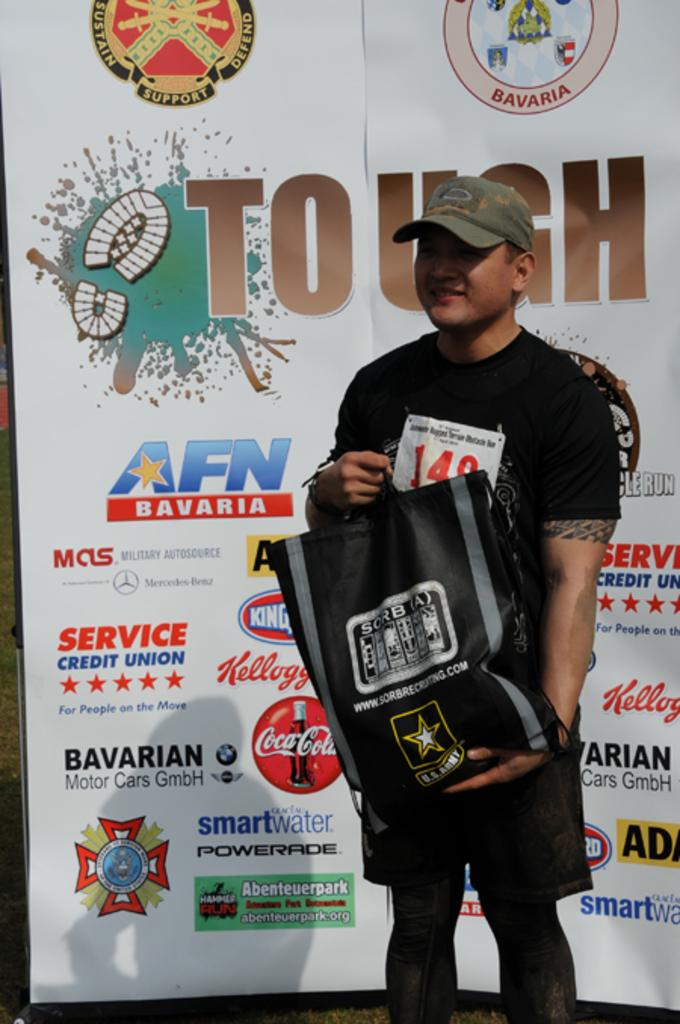What is the main subject of the image? There is a person in the image. What is the person holding in the image? The person is holding a bag. What is the person wearing on their head in the image? The person is wearing a cap. What can be seen on the wall in the image? There is a poster in the image. What is written or depicted on the poster? The poster has some text and logo symbols. How many pickles are on the person's head in the image? There are no pickles present in the image, and the person is wearing a cap, not pickles. Can you see any mice running around in the image? There are no mice present in the image. 